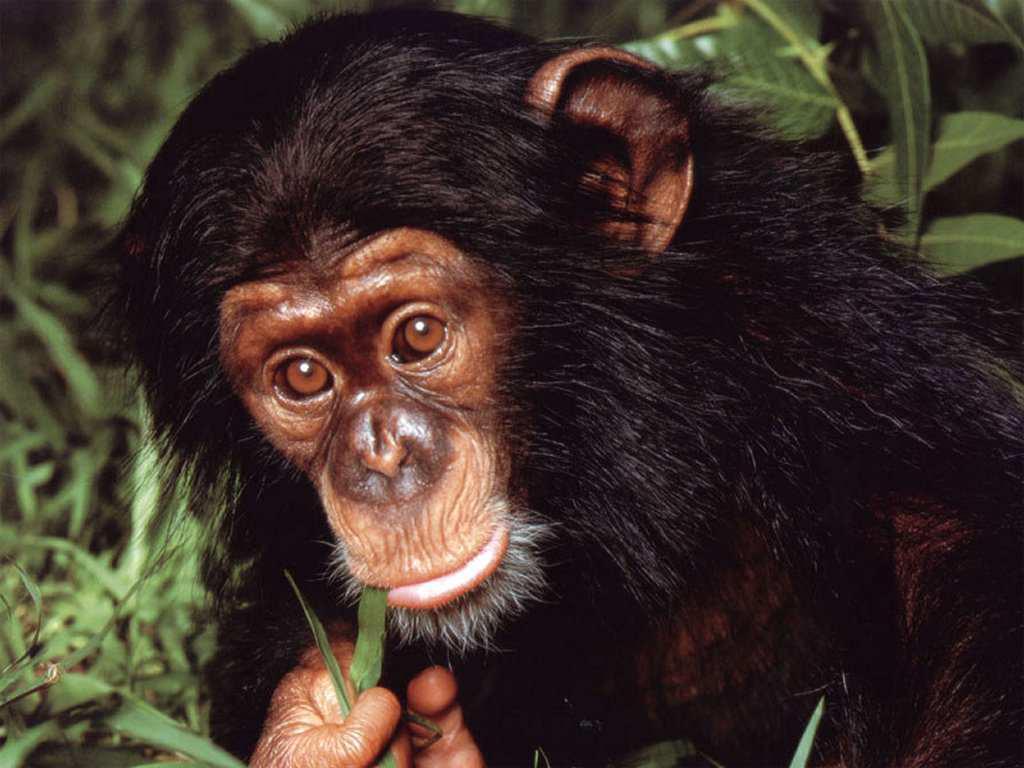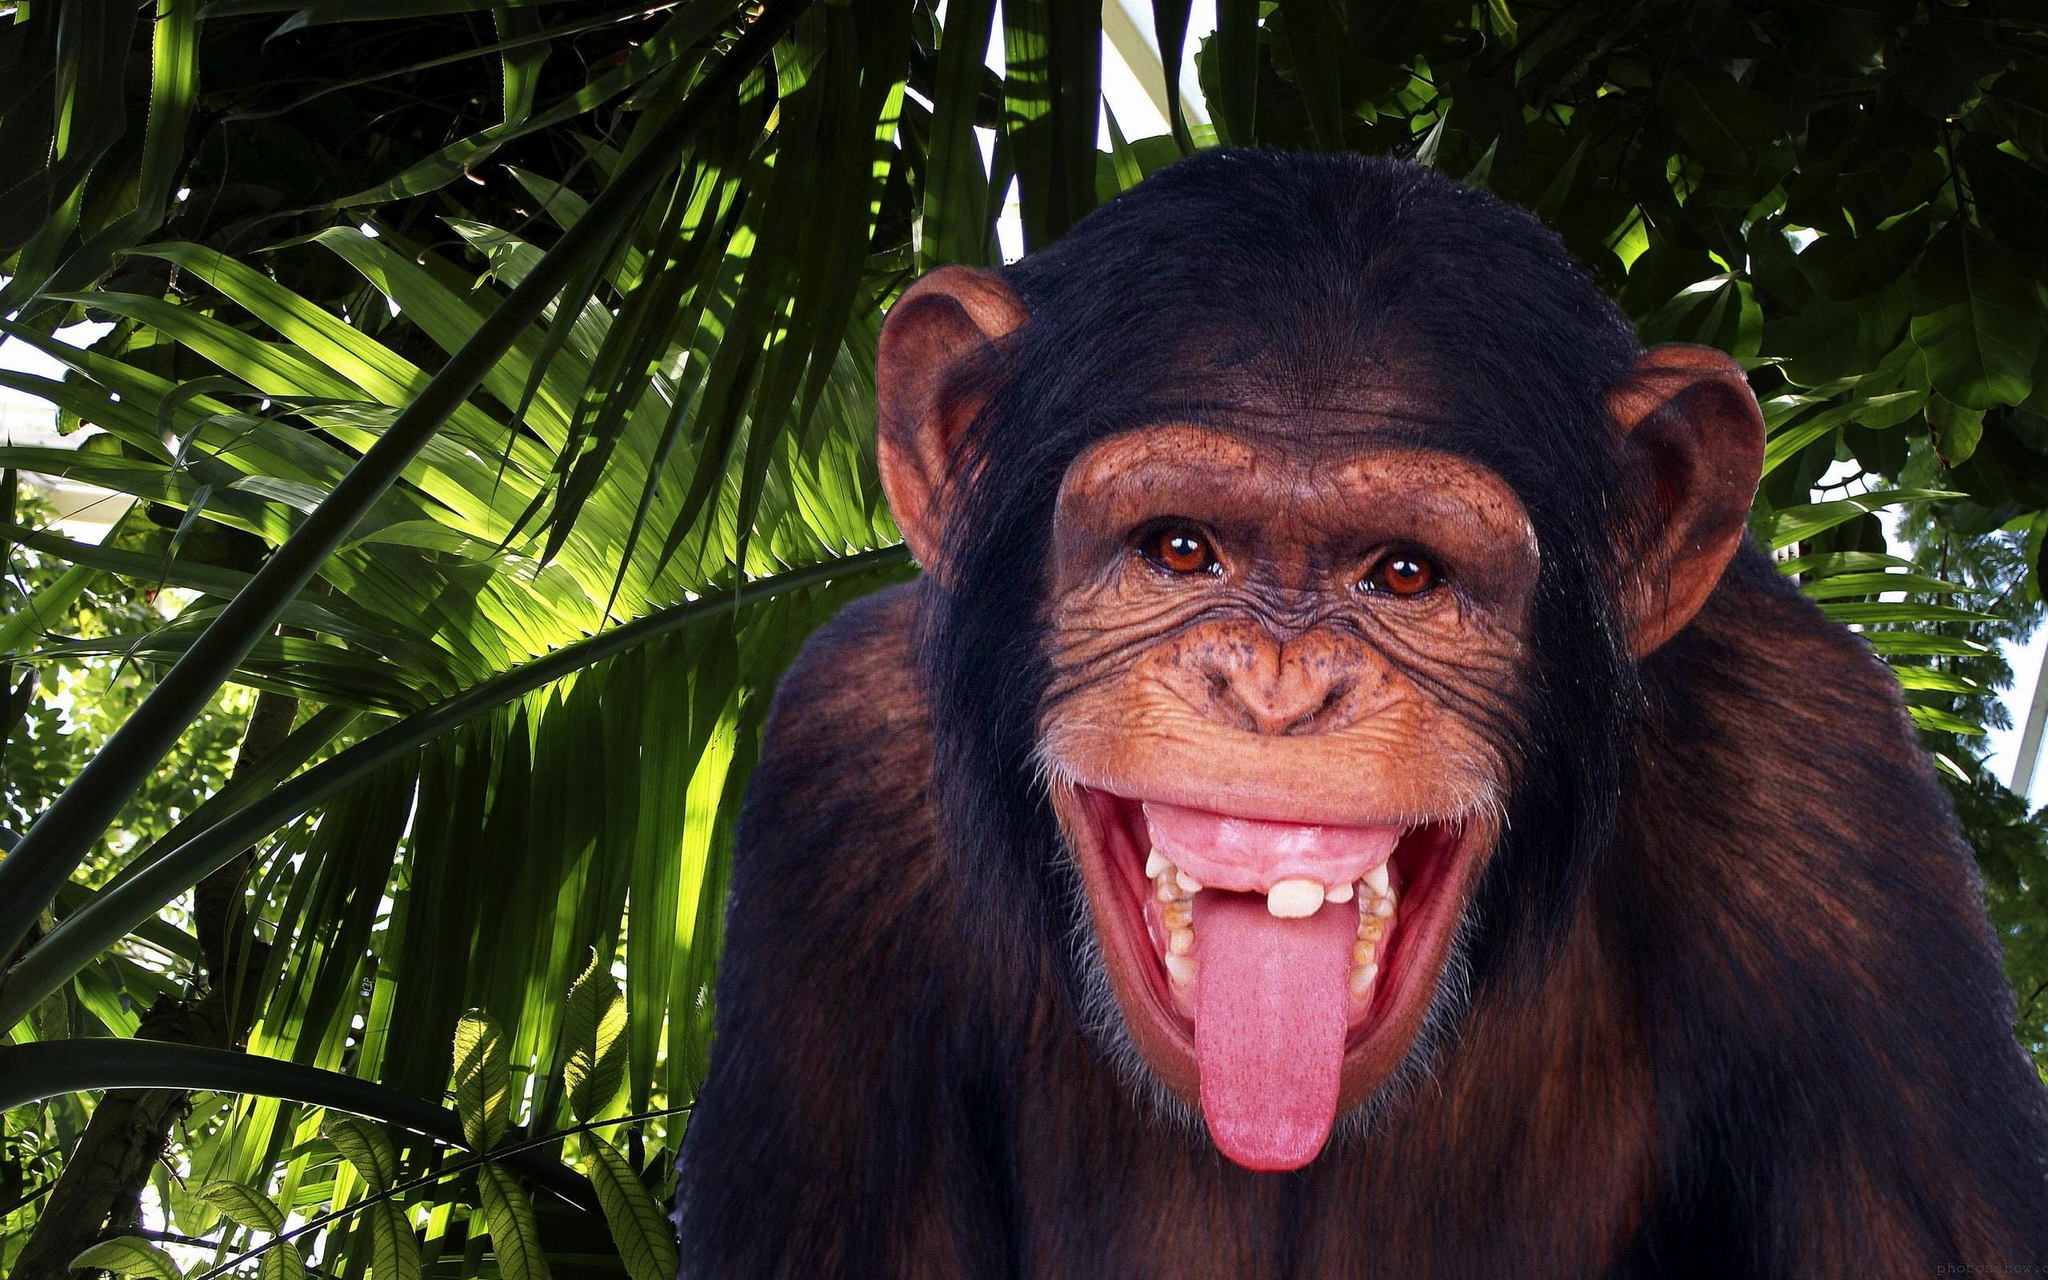The first image is the image on the left, the second image is the image on the right. Examine the images to the left and right. Is the description "In one of the images, a young chimp places something in its mouth." accurate? Answer yes or no. Yes. The first image is the image on the left, the second image is the image on the right. For the images shown, is this caption "A small monkey eats leaves." true? Answer yes or no. Yes. 